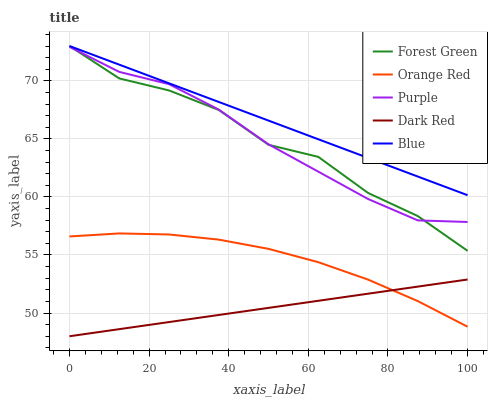Does Dark Red have the minimum area under the curve?
Answer yes or no. Yes. Does Blue have the maximum area under the curve?
Answer yes or no. Yes. Does Forest Green have the minimum area under the curve?
Answer yes or no. No. Does Forest Green have the maximum area under the curve?
Answer yes or no. No. Is Dark Red the smoothest?
Answer yes or no. Yes. Is Forest Green the roughest?
Answer yes or no. Yes. Is Forest Green the smoothest?
Answer yes or no. No. Is Dark Red the roughest?
Answer yes or no. No. Does Dark Red have the lowest value?
Answer yes or no. Yes. Does Forest Green have the lowest value?
Answer yes or no. No. Does Blue have the highest value?
Answer yes or no. Yes. Does Dark Red have the highest value?
Answer yes or no. No. Is Orange Red less than Purple?
Answer yes or no. Yes. Is Forest Green greater than Dark Red?
Answer yes or no. Yes. Does Dark Red intersect Orange Red?
Answer yes or no. Yes. Is Dark Red less than Orange Red?
Answer yes or no. No. Is Dark Red greater than Orange Red?
Answer yes or no. No. Does Orange Red intersect Purple?
Answer yes or no. No. 